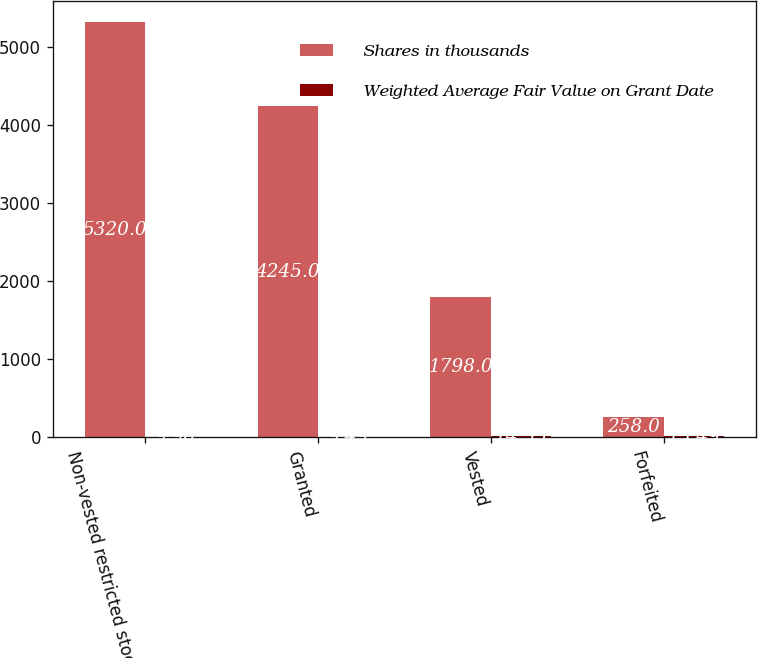<chart> <loc_0><loc_0><loc_500><loc_500><stacked_bar_chart><ecel><fcel>Non-vested restricted stock at<fcel>Granted<fcel>Vested<fcel>Forfeited<nl><fcel>Shares in thousands<fcel>5320<fcel>4245<fcel>1798<fcel>258<nl><fcel>Weighted Average Fair Value on Grant Date<fcel>9.98<fcel>9.49<fcel>14.55<fcel>15.49<nl></chart> 